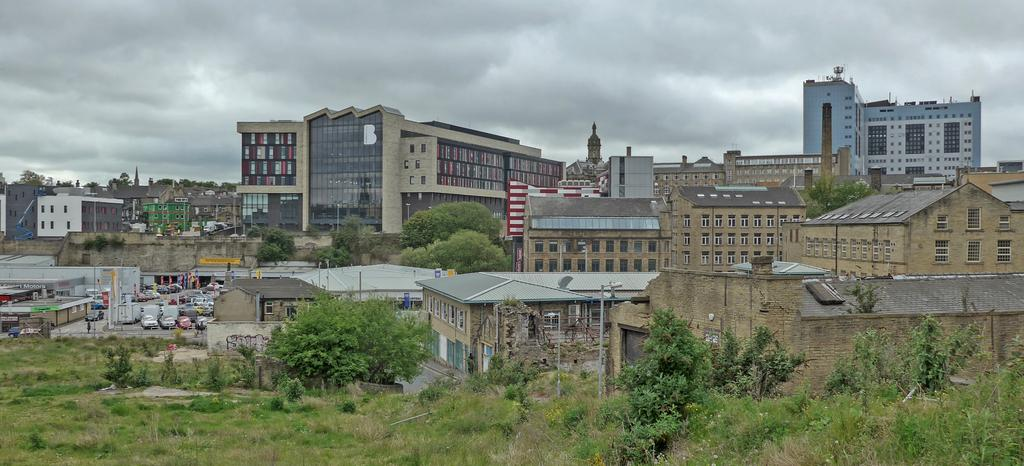What type of structures can be seen in the image? There are buildings in the image. What else is present in the image besides buildings? There are vehicles and trees visible in the image. Are there any living organisms in the image? Yes, there are plants in the image. What can be seen in the background of the image? The sky is visible in the background of the image. What advice does the ladybug give to the father in the image? There is no ladybug or father present in the image, so no such advice can be given. 